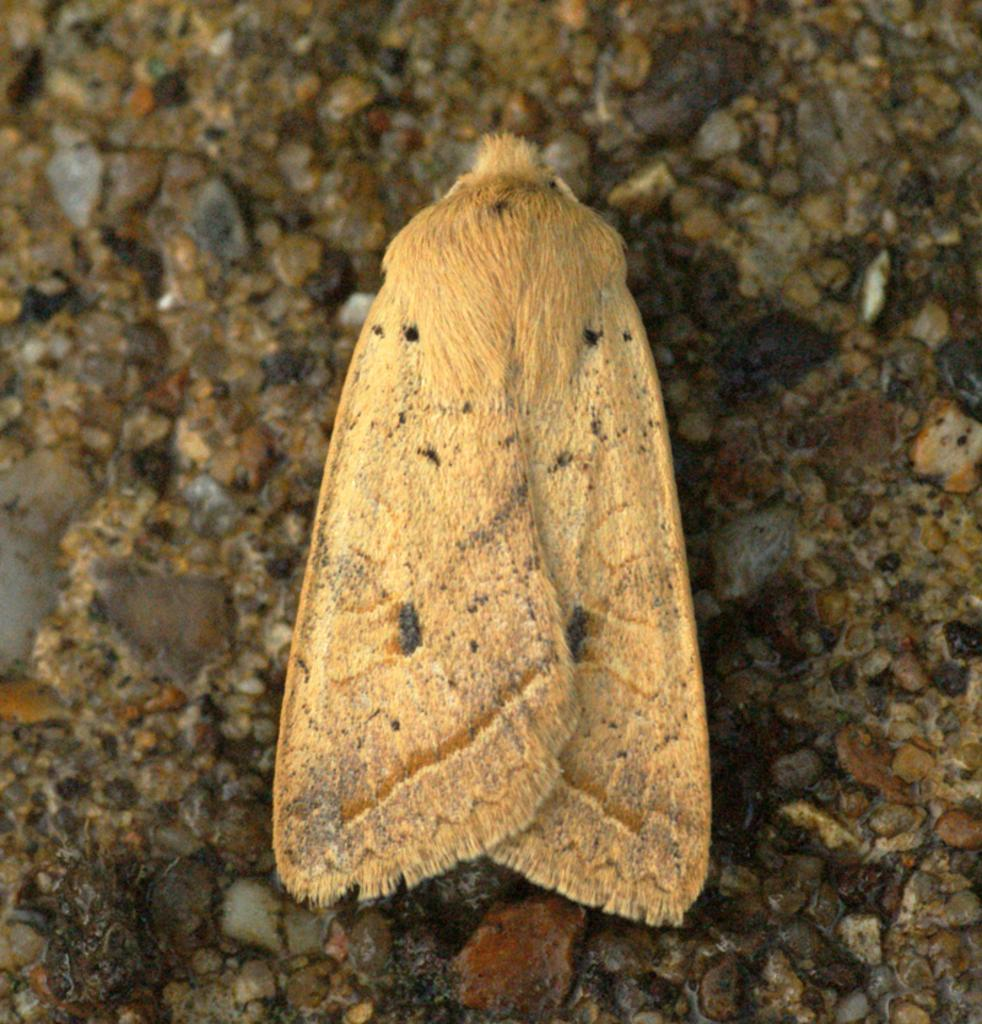What type of creature can be seen in the image? There is an insect in the image. Where is the insect located? The insect is on the sand. Can you tell me how many people are swimming in the image? There are no people swimming in the image, as it only features an insect on the sand. What type of alarm is going off in the image? There is no alarm present in the image; it only features an insect on the sand. 